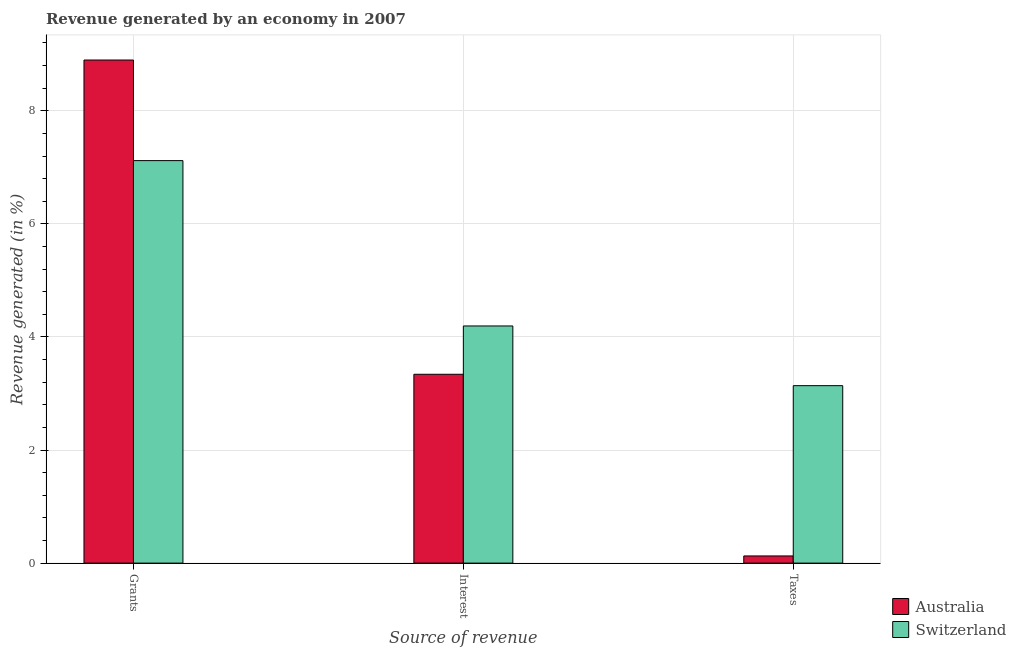How many different coloured bars are there?
Your answer should be compact. 2. Are the number of bars per tick equal to the number of legend labels?
Provide a succinct answer. Yes. Are the number of bars on each tick of the X-axis equal?
Keep it short and to the point. Yes. How many bars are there on the 2nd tick from the right?
Your answer should be very brief. 2. What is the label of the 1st group of bars from the left?
Offer a terse response. Grants. What is the percentage of revenue generated by taxes in Australia?
Provide a succinct answer. 0.13. Across all countries, what is the maximum percentage of revenue generated by taxes?
Offer a terse response. 3.14. Across all countries, what is the minimum percentage of revenue generated by taxes?
Your answer should be compact. 0.13. In which country was the percentage of revenue generated by interest maximum?
Give a very brief answer. Switzerland. In which country was the percentage of revenue generated by grants minimum?
Keep it short and to the point. Switzerland. What is the total percentage of revenue generated by interest in the graph?
Provide a succinct answer. 7.53. What is the difference between the percentage of revenue generated by grants in Switzerland and that in Australia?
Provide a short and direct response. -1.78. What is the difference between the percentage of revenue generated by grants in Switzerland and the percentage of revenue generated by taxes in Australia?
Give a very brief answer. 6.99. What is the average percentage of revenue generated by interest per country?
Your answer should be compact. 3.77. What is the difference between the percentage of revenue generated by grants and percentage of revenue generated by interest in Switzerland?
Offer a terse response. 2.92. What is the ratio of the percentage of revenue generated by taxes in Australia to that in Switzerland?
Provide a succinct answer. 0.04. Is the percentage of revenue generated by taxes in Australia less than that in Switzerland?
Make the answer very short. Yes. Is the difference between the percentage of revenue generated by interest in Australia and Switzerland greater than the difference between the percentage of revenue generated by taxes in Australia and Switzerland?
Make the answer very short. Yes. What is the difference between the highest and the second highest percentage of revenue generated by grants?
Provide a succinct answer. 1.78. What is the difference between the highest and the lowest percentage of revenue generated by taxes?
Provide a short and direct response. 3.01. What does the 2nd bar from the left in Interest represents?
Offer a terse response. Switzerland. What does the 1st bar from the right in Taxes represents?
Keep it short and to the point. Switzerland. How many countries are there in the graph?
Your response must be concise. 2. Does the graph contain any zero values?
Ensure brevity in your answer.  No. Does the graph contain grids?
Provide a succinct answer. Yes. Where does the legend appear in the graph?
Provide a short and direct response. Bottom right. How many legend labels are there?
Your answer should be compact. 2. What is the title of the graph?
Provide a short and direct response. Revenue generated by an economy in 2007. Does "Namibia" appear as one of the legend labels in the graph?
Offer a terse response. No. What is the label or title of the X-axis?
Provide a short and direct response. Source of revenue. What is the label or title of the Y-axis?
Your answer should be compact. Revenue generated (in %). What is the Revenue generated (in %) of Australia in Grants?
Provide a short and direct response. 8.9. What is the Revenue generated (in %) in Switzerland in Grants?
Provide a short and direct response. 7.12. What is the Revenue generated (in %) of Australia in Interest?
Your answer should be compact. 3.34. What is the Revenue generated (in %) of Switzerland in Interest?
Give a very brief answer. 4.19. What is the Revenue generated (in %) in Australia in Taxes?
Offer a terse response. 0.13. What is the Revenue generated (in %) in Switzerland in Taxes?
Ensure brevity in your answer.  3.14. Across all Source of revenue, what is the maximum Revenue generated (in %) in Australia?
Your answer should be compact. 8.9. Across all Source of revenue, what is the maximum Revenue generated (in %) of Switzerland?
Your answer should be compact. 7.12. Across all Source of revenue, what is the minimum Revenue generated (in %) of Australia?
Ensure brevity in your answer.  0.13. Across all Source of revenue, what is the minimum Revenue generated (in %) in Switzerland?
Offer a very short reply. 3.14. What is the total Revenue generated (in %) in Australia in the graph?
Offer a very short reply. 12.37. What is the total Revenue generated (in %) of Switzerland in the graph?
Keep it short and to the point. 14.45. What is the difference between the Revenue generated (in %) of Australia in Grants and that in Interest?
Your answer should be very brief. 5.56. What is the difference between the Revenue generated (in %) of Switzerland in Grants and that in Interest?
Offer a very short reply. 2.92. What is the difference between the Revenue generated (in %) in Australia in Grants and that in Taxes?
Your answer should be compact. 8.77. What is the difference between the Revenue generated (in %) in Switzerland in Grants and that in Taxes?
Give a very brief answer. 3.98. What is the difference between the Revenue generated (in %) in Australia in Interest and that in Taxes?
Your answer should be very brief. 3.21. What is the difference between the Revenue generated (in %) in Switzerland in Interest and that in Taxes?
Make the answer very short. 1.06. What is the difference between the Revenue generated (in %) of Australia in Grants and the Revenue generated (in %) of Switzerland in Interest?
Your answer should be very brief. 4.7. What is the difference between the Revenue generated (in %) of Australia in Grants and the Revenue generated (in %) of Switzerland in Taxes?
Give a very brief answer. 5.76. What is the difference between the Revenue generated (in %) of Australia in Interest and the Revenue generated (in %) of Switzerland in Taxes?
Your answer should be compact. 0.2. What is the average Revenue generated (in %) of Australia per Source of revenue?
Ensure brevity in your answer.  4.12. What is the average Revenue generated (in %) in Switzerland per Source of revenue?
Offer a terse response. 4.82. What is the difference between the Revenue generated (in %) in Australia and Revenue generated (in %) in Switzerland in Grants?
Make the answer very short. 1.78. What is the difference between the Revenue generated (in %) of Australia and Revenue generated (in %) of Switzerland in Interest?
Keep it short and to the point. -0.85. What is the difference between the Revenue generated (in %) in Australia and Revenue generated (in %) in Switzerland in Taxes?
Offer a terse response. -3.01. What is the ratio of the Revenue generated (in %) of Australia in Grants to that in Interest?
Your answer should be compact. 2.66. What is the ratio of the Revenue generated (in %) in Switzerland in Grants to that in Interest?
Your answer should be very brief. 1.7. What is the ratio of the Revenue generated (in %) in Australia in Grants to that in Taxes?
Keep it short and to the point. 70.11. What is the ratio of the Revenue generated (in %) of Switzerland in Grants to that in Taxes?
Make the answer very short. 2.27. What is the ratio of the Revenue generated (in %) in Australia in Interest to that in Taxes?
Offer a very short reply. 26.32. What is the ratio of the Revenue generated (in %) of Switzerland in Interest to that in Taxes?
Offer a very short reply. 1.34. What is the difference between the highest and the second highest Revenue generated (in %) in Australia?
Provide a short and direct response. 5.56. What is the difference between the highest and the second highest Revenue generated (in %) in Switzerland?
Offer a very short reply. 2.92. What is the difference between the highest and the lowest Revenue generated (in %) in Australia?
Give a very brief answer. 8.77. What is the difference between the highest and the lowest Revenue generated (in %) of Switzerland?
Your answer should be compact. 3.98. 